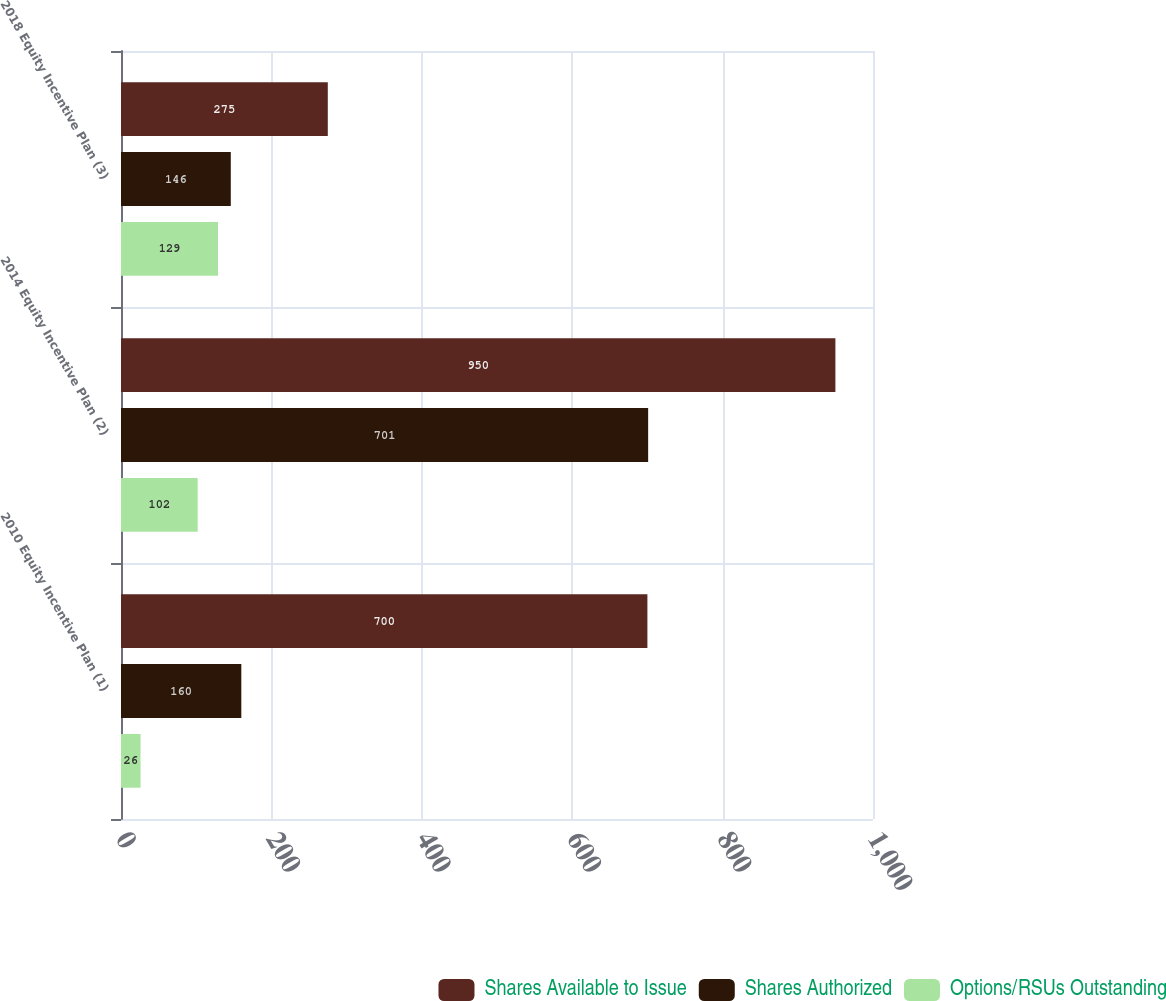<chart> <loc_0><loc_0><loc_500><loc_500><stacked_bar_chart><ecel><fcel>2010 Equity Incentive Plan (1)<fcel>2014 Equity Incentive Plan (2)<fcel>2018 Equity Incentive Plan (3)<nl><fcel>Shares Available to Issue<fcel>700<fcel>950<fcel>275<nl><fcel>Shares Authorized<fcel>160<fcel>701<fcel>146<nl><fcel>Options/RSUs Outstanding<fcel>26<fcel>102<fcel>129<nl></chart> 